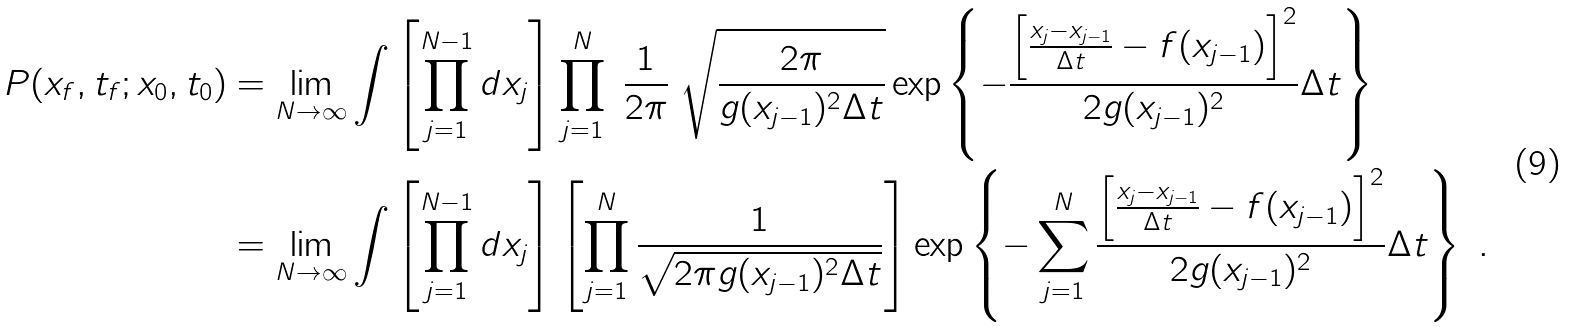Convert formula to latex. <formula><loc_0><loc_0><loc_500><loc_500>P ( x _ { f } , t _ { f } ; x _ { 0 } , t _ { 0 } ) & = \lim _ { N \to \infty } \int \left [ \prod _ { j = 1 } ^ { N - 1 } d x _ { j } \right ] \prod _ { j = 1 } ^ { N } \ \frac { 1 } { 2 \pi } \ \sqrt { \frac { 2 \pi } { g ( x _ { j - 1 } ) ^ { 2 } \Delta t } } \exp \left \{ - \frac { \left [ \frac { x _ { j } - x _ { j - 1 } } { \Delta t } - f ( x _ { j - 1 } ) \right ] ^ { 2 } } { 2 g ( x _ { j - 1 } ) ^ { 2 } } \Delta t \right \} \\ & = \lim _ { N \to \infty } \int \left [ \prod _ { j = 1 } ^ { N - 1 } d x _ { j } \right ] \left [ \prod _ { j = 1 } ^ { N } \frac { 1 } { \sqrt { 2 \pi g ( x _ { j - 1 } ) ^ { 2 } \Delta t } } \right ] \exp \left \{ - \sum _ { j = 1 } ^ { N } \frac { \left [ \frac { x _ { j } - x _ { j - 1 } } { \Delta t } - f ( x _ { j - 1 } ) \right ] ^ { 2 } } { 2 g ( x _ { j - 1 } ) ^ { 2 } } \Delta t \right \} \ .</formula> 